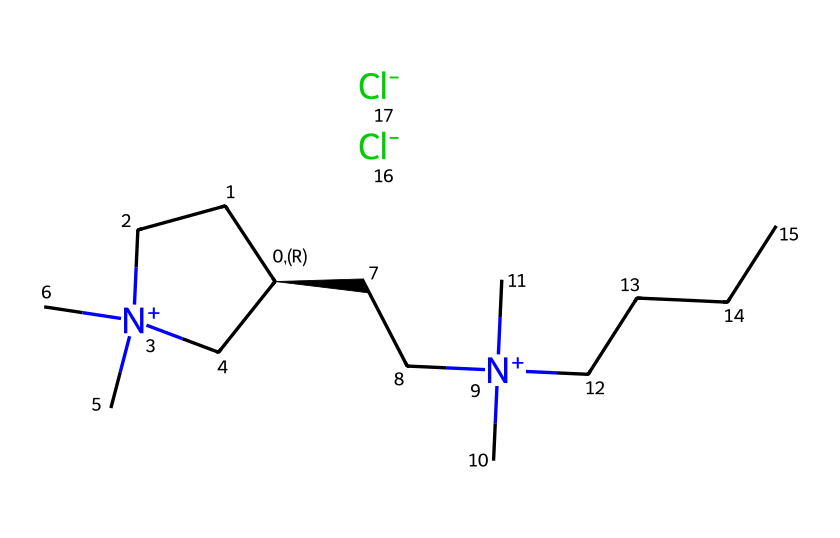What is the number of nitrogen atoms in this ionic liquid? The SMILES representation contains two instances of "[N+]", indicating two nitrogen atoms. Nitrogen is essential for the structure of ionic liquids as it forms the cationic part of the compound.
Answer: 2 How many chlorine ions are associated with this ionic liquid? The notation "[Cl-]" appears twice in the SMILES string, indicating two chloride ions connected to the ionic liquid. Chloride ions are typical counterparts to the cation in ionic liquids.
Answer: 2 What type of compound is this? The presence of a cation with a positive charge and an anion (chloride) classifies this compound as an ionic liquid. Ionic liquids are characterized by their liquid state at room temperature and their ionic nature.
Answer: ionic liquid Which part of the molecular structure contributes to its long-lasting properties? The large cationic components including multiple alkyl chains contribute to the viscosity and stability of the formulation, allowing it to adhere longer on skin or surfaces, essential for cosmetics durability.
Answer: cationic components What is the likely role of the chloride ions in this ionic liquid? Chloride ions serve as the anionic counterpart to the cation, helping to balance the charge and stabilize the liquid state. This charge neutrality is critical for ionic liquids.
Answer: charge balance How can we identify that this is a multi-chain ionic liquid? The presence of multiple long carbon chains connected to the nitrogen atoms indicates that there are several alkyl groups, giving it a complex structure typical of multi-chain ionic liquids.
Answer: multi-chain How many carbon atoms are present in this structure? Counting the carbon atoms from the structure represented in the SMILES gives a total of 13 carbon atoms bonded in various ways. This count confirms the saturation of carbon-containing constituents in the ionic liquid.
Answer: 13 